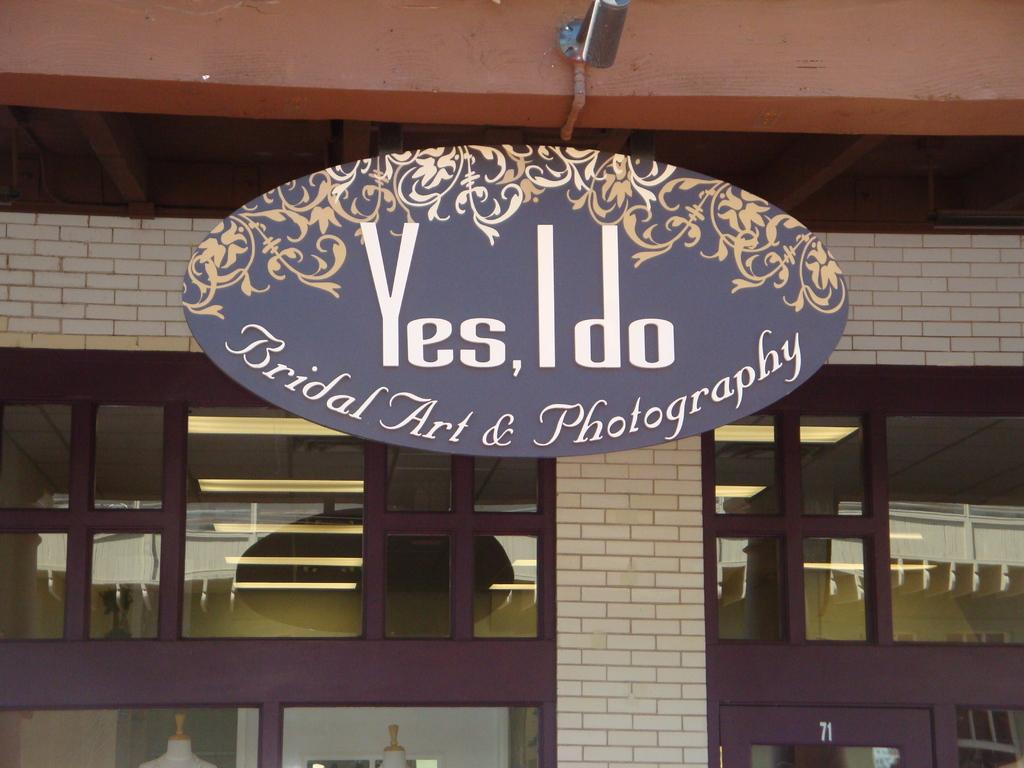<image>
Create a compact narrative representing the image presented. yes I do is the name of this cute little photography studio 